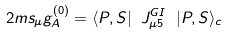Convert formula to latex. <formula><loc_0><loc_0><loc_500><loc_500>2 m s _ { \mu } g _ { A } ^ { ( 0 ) } = \langle P , S | \ J ^ { G I } _ { \mu 5 } \ | P , S \rangle _ { c }</formula> 